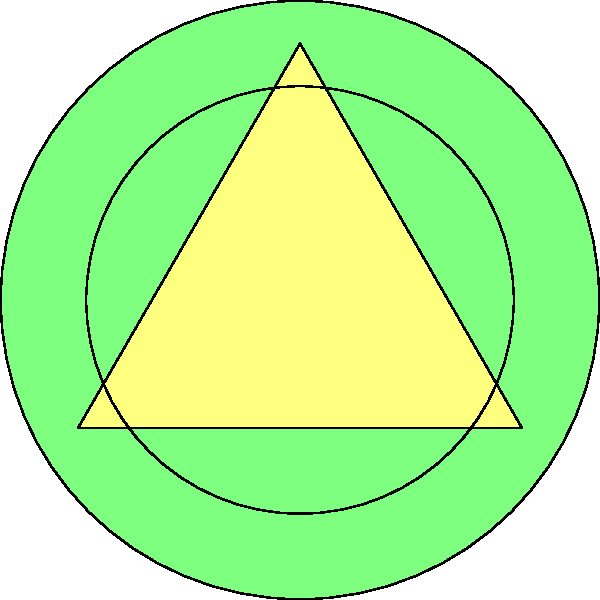Which concept best represents the synergy between Mayling Ng's martial arts expertise, potential film projects, and dynamic action sequences? To answer this question, let's analyze the relationships depicted in the diagram:

1. The diagram shows three interconnected elements: Martial Arts, Film Project, and Action Scene.
2. Martial Arts is connected to both Film Project and Action Scene, indicating that Mayling Ng's martial arts skills can directly influence both aspects.
3. Film Project is also connected to Action Scene, suggesting that the project itself shapes the action sequences.
4. The triangular relationship between these elements implies a synergistic connection.
5. In film production, this synergy is often referred to as "choreography" - the art of designing and coordinating complex movements, especially in action scenes.
6. Choreography in this context would involve integrating Mayling Ng's martial arts skills into the film project's action scenes, creating a cohesive and dynamic visual spectacle.

Therefore, the concept that best represents this synergy is choreography, as it encapsulates the integration of Mayling Ng's martial arts expertise into the film project's action sequences.
Answer: Choreography 